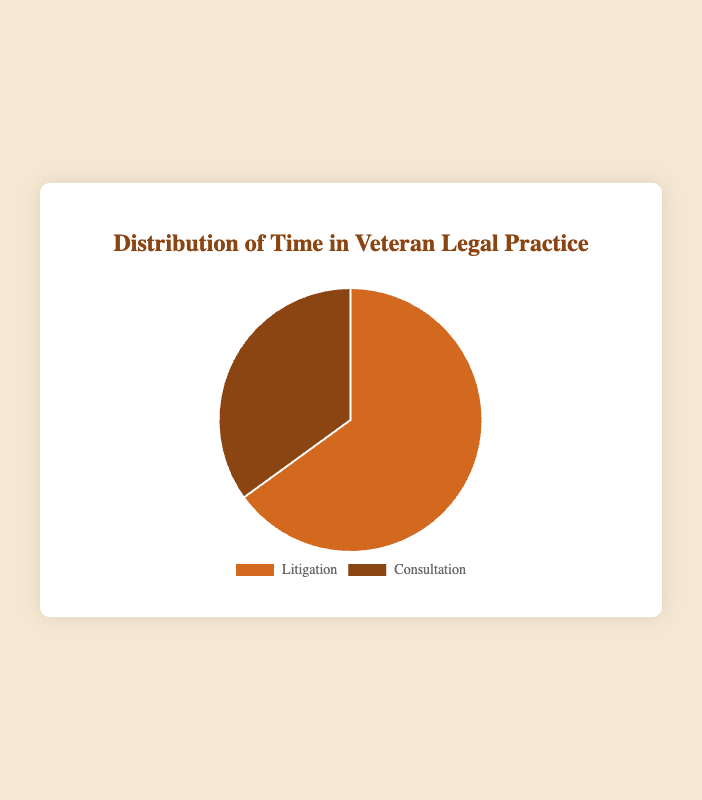What is the percentage of time spent on litigation? The slice labeled "Litigation" shows 65%. The chart indicates that 65% of the time is devoted to litigation.
Answer: 65% Which activity consumes less time, litigation or consultation? By comparing the percentages in the chart, it's evident that consultation (35%) consumes less time than litigation (65%).
Answer: Consultation How much more time is spent on litigation compared to consultation? To find the difference, subtract the percentage for consultation from that for litigation: 65% - 35% = 30%. Therefore, 30% more time is spent on litigation.
Answer: 30% What fraction of the total time is used for consultation, expressed as a percentage? The section labeled "Consultation" is 35% of the total, which represents the fraction of time spent on consultation.
Answer: 35% If the total work time is 100 hours, how many hours are spent on consultation? Given that 35% of the total time is spent on consultation, calculate 35% of 100 hours: 100 * 0.35 = 35 hours.
Answer: 35 hours What is the ratio of time spent on litigation to consultation? The ratio can be found using the percentages for each activity: 65% for litigation and 35% for consultation. Simplifying the ratio 65:35 gives 13:7.
Answer: 13:7 How would the chart change if consultation time were increased by 10%? Adding 10% to the current consultation time increases it to 45%. Since the total must still be 100%, the new percentages are: Litigation 55% and Consultation 45%.
Answer: Litigation 55%, Consultation 45% Which color represents the consultation time? The chart uses two colors: brownish shades; the consultation slice is represented by the darker brown shade.
Answer: Dark brown What are the colors of the two slices of the pie chart? The chart uses two distinct colors: one for litigation and one for consultation. Litigation is shown in a lighter brown, and consultation in a darker brown.
Answer: Lighter brown (litigation), Darker brown (consultation) How does the distribution highlight areas of focus in a veteran legal practice? The chart shows a larger portion dedicated to litigation at 65%, indicating that a significant amount of time is spent on litigation compared to consultation, which is 35%. This distribution emphasizes a greater focus on litigation activities.
Answer: Greater focus on litigation 